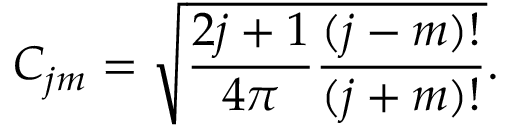Convert formula to latex. <formula><loc_0><loc_0><loc_500><loc_500>C _ { j m } = \sqrt { \frac { 2 j + 1 } { 4 \pi } \frac { ( j - m ) ! } { ( j + m ) ! } } .</formula> 